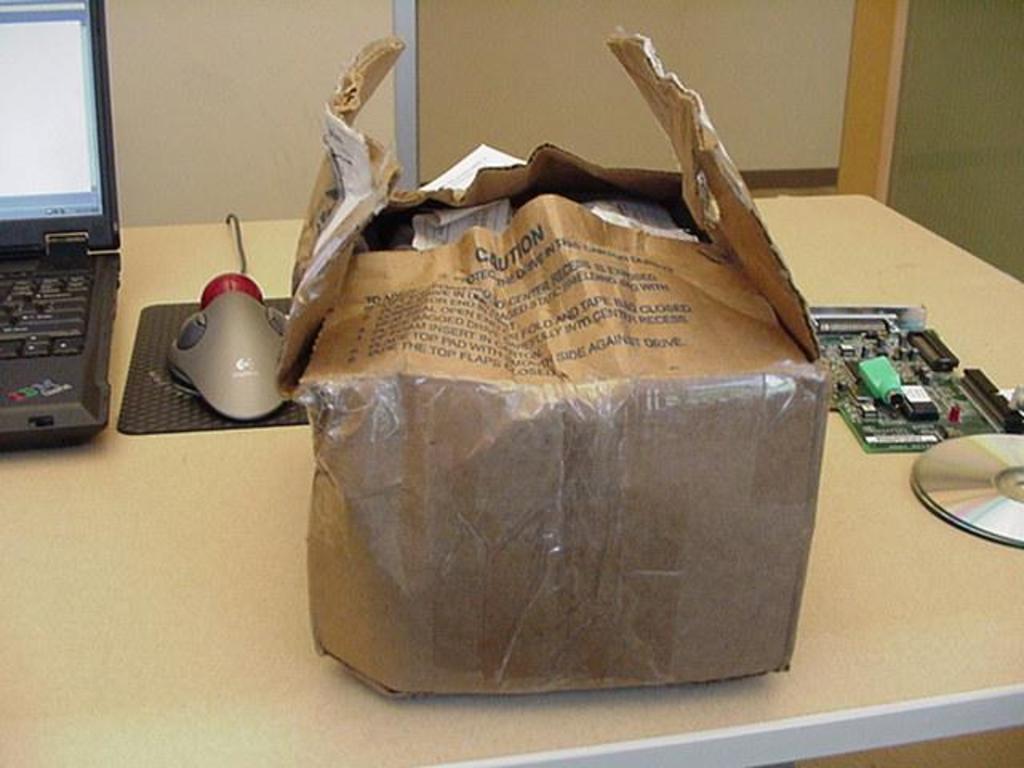Can you describe this image briefly? A cardboard box, laptop, mouse, VGA card and two CD ROMs are on a table. 